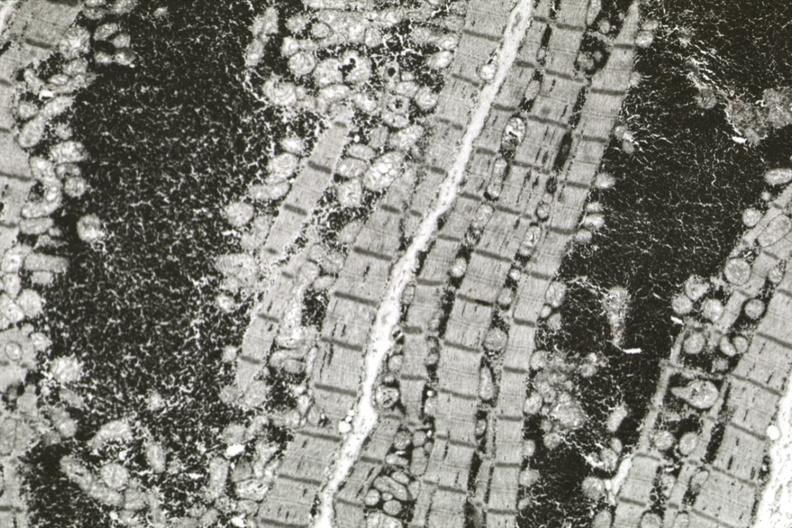what is present?
Answer the question using a single word or phrase. Cardiovascular 